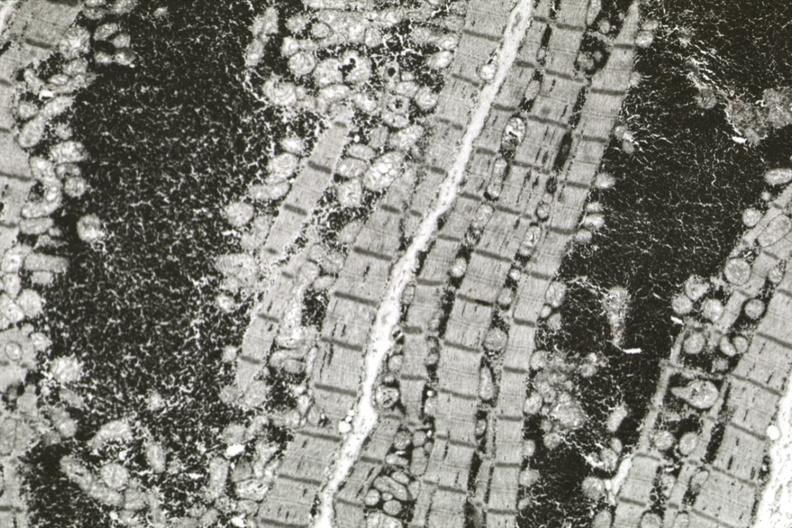what is present?
Answer the question using a single word or phrase. Cardiovascular 